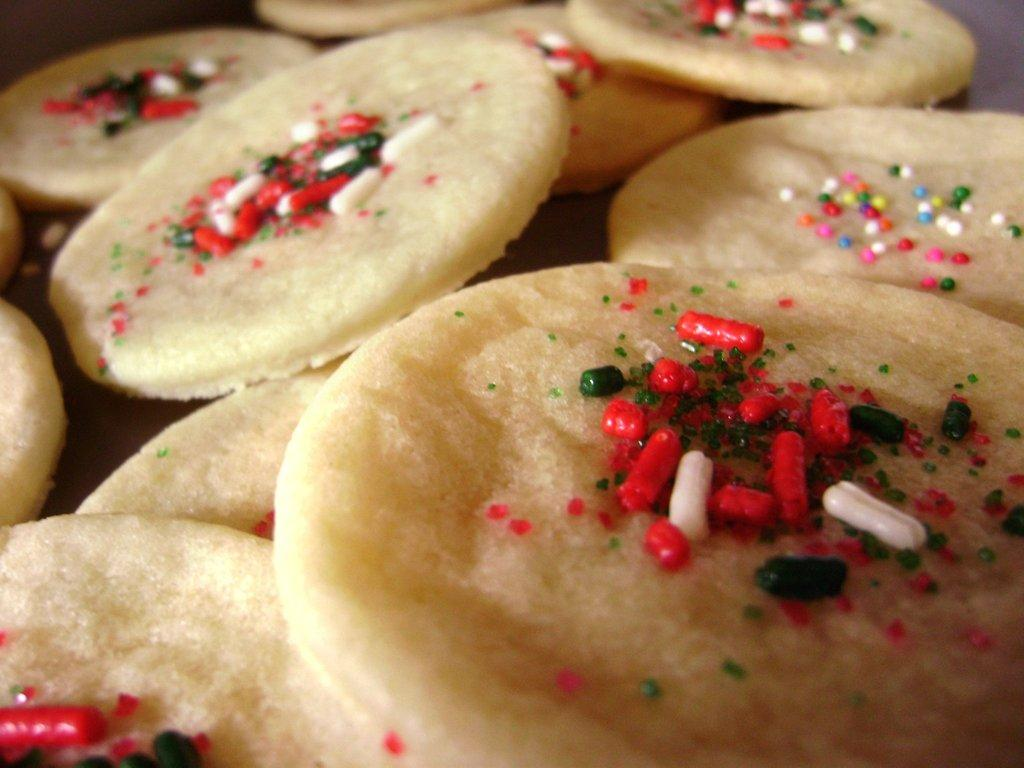What is the main subject of the image? The main subject of the image is food items. What type of boot is being used to drive the food items in the image? There is no boot or driving depicted in the image; it only features food items in the center. 